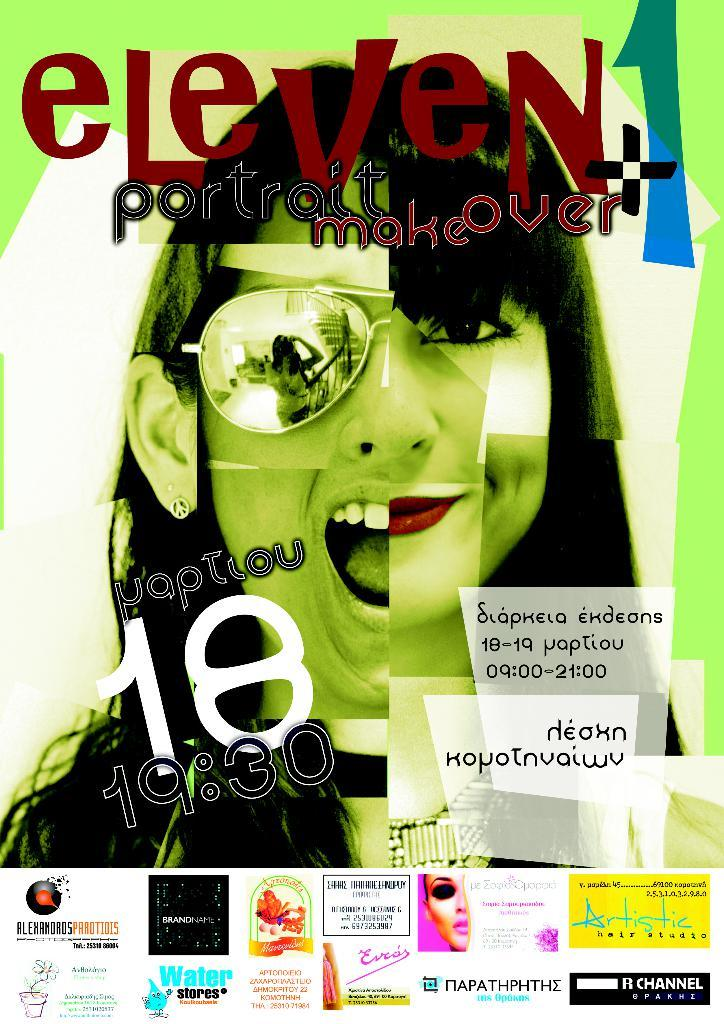What is present on the poster in the image? The poster contains words, numbers, and images of persons. Can you describe the content of the poster in more detail? The poster contains words, numbers, and images of persons, which suggests it might be a poster with information or a message. What type of polish is being applied to the poster in the image? There is no polish present in the image, nor is there any indication that the poster is being polished. 